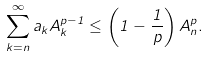Convert formula to latex. <formula><loc_0><loc_0><loc_500><loc_500>\sum ^ { \infty } _ { k = n } a _ { k } A ^ { p - 1 } _ { k } \leq \left ( 1 - \frac { 1 } { p } \right ) A ^ { p } _ { n } .</formula> 